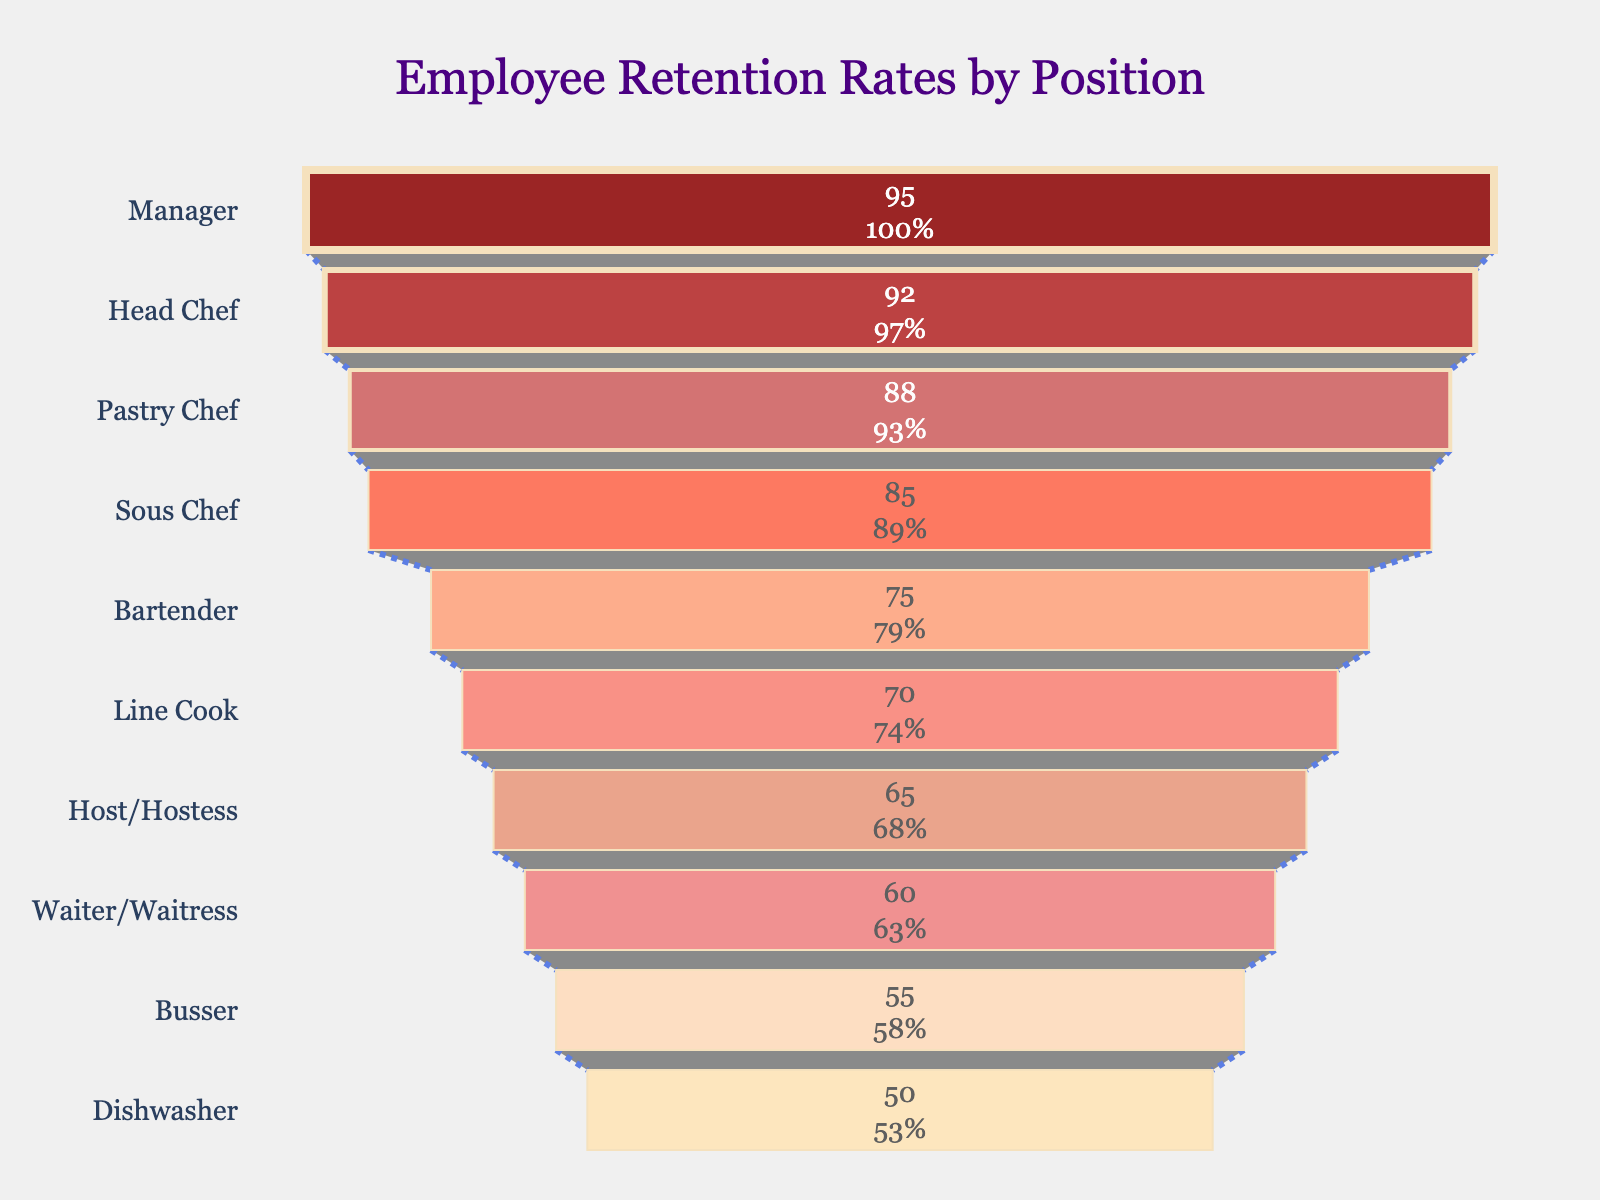What's the title of the chart? The title of the chart is placed at the top center and reads "Employee Retention Rates by Position."
Answer: Employee Retention Rates by Position How many positions are listed in the chart? By counting the number of unique funnel sections, each representing one position, you can determine there are 10 positions listed.
Answer: 10 Which position has the highest retention rate? The position with the highest retention rate is at the top of the funnel chart and labeled "Manager" with a retention rate of 95%.
Answer: Manager What is the retention rate of the position at the bottom of the funnel? The bottom position in the funnel chart is labeled "Dishwasher," with a retention rate of 50%.
Answer: 50% How many positions have a retention rate above 80%? There are 5 positions with retention rates above 80%: Manager, Head Chef, Pastry Chef, Sous Chef, and Bartender.
Answer: 5 What is the difference in retention rates between a Waiter/Waitress and a Head Chef? A Waiter/Waitress has a retention rate of 60%, while a Head Chef has a retention rate of 92%. The difference is 92% - 60% = 32%.
Answer: 32% What is the average retention rate for the positions listed in the chart? To find the average, sum all retention rates and divide by the number of positions: (92 + 85 + 70 + 88 + 65 + 60 + 75 + 55 + 50 + 95) / 10 = 735 / 10 = 73.5%.
Answer: 73.5% Which positions have a retention rate below the average rate? The average retention rate is 73.5%. Positions below this rate include Line Cook (70%), Host/Hostess (65%), Waiter/Waitress (60%), Busser (55%), and Dishwasher (50%).
Answer: 5 Is the retention rate of a Busser higher or lower than that of a Bartender? The Busser has a retention rate of 55%, which is lower than the 75% retention rate of the Bartender.
Answer: Lower What percentage of positions have a retention rate of 75% or higher? To calculate this, identify the positions with 75% or higher (Manager, Head Chef, Sous Chef, Pastry Chef, and Bartender). There are 5 out of 10 positions, so (5/10) * 100 = 50%.
Answer: 50% 